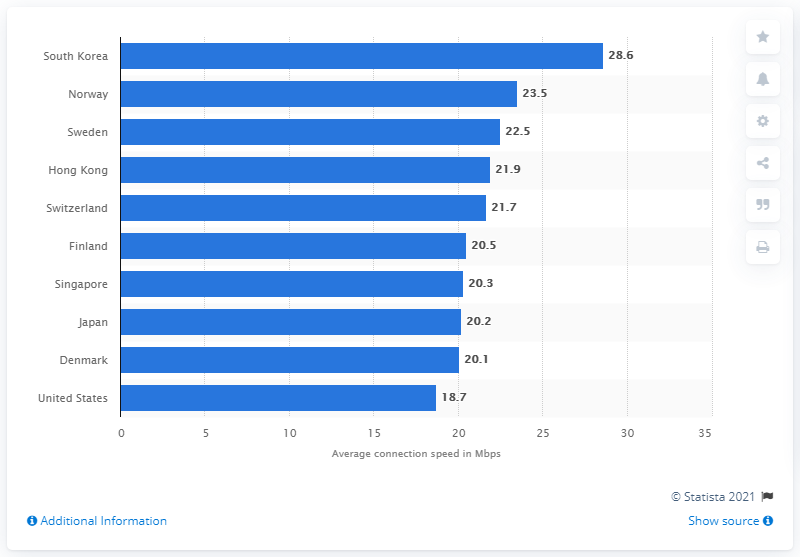Mention a couple of crucial points in this snapshot. The y-axis in the scatter plot is labeled "Country Name," indicating the name of each country represented in the plot. Norway had the highest average connection speed during the first quarter of 2017 among all countries. The difference between the highest and lowest bar in the graph is 9.9. 